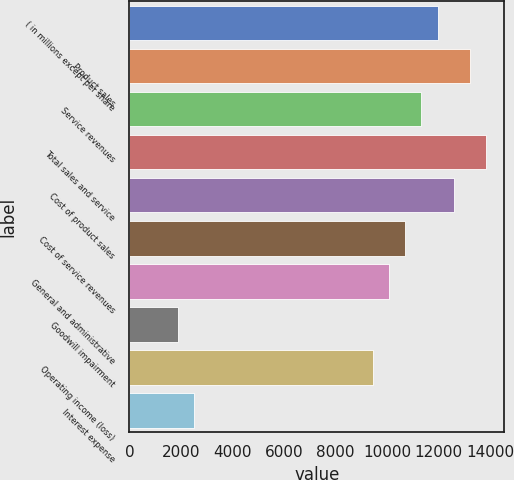Convert chart. <chart><loc_0><loc_0><loc_500><loc_500><bar_chart><fcel>( in millions except per share<fcel>Product sales<fcel>Service revenues<fcel>Total sales and service<fcel>Cost of product sales<fcel>Cost of service revenues<fcel>General and administrative<fcel>Goodwill impairment<fcel>Operating income (loss)<fcel>Interest expense<nl><fcel>11953.9<fcel>13212.1<fcel>11324.8<fcel>13841.2<fcel>12583<fcel>10695.7<fcel>10066.6<fcel>1888.3<fcel>9437.5<fcel>2517.4<nl></chart> 